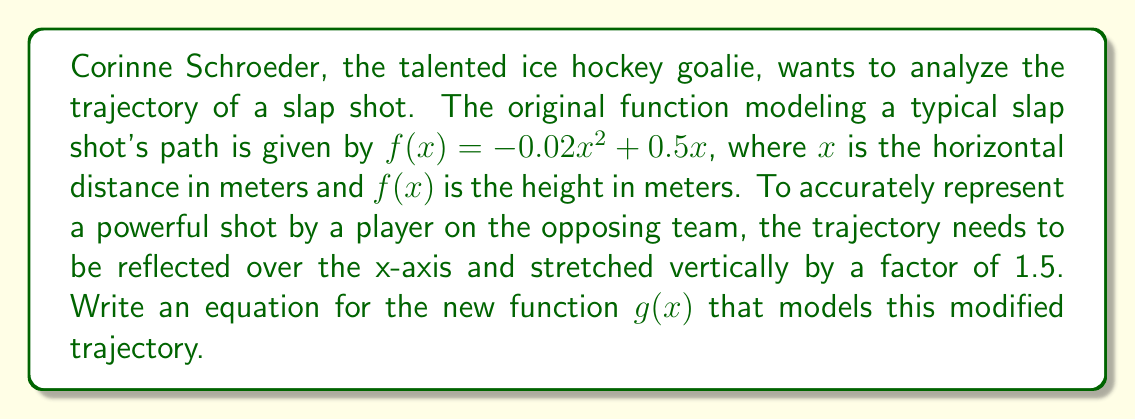Provide a solution to this math problem. To solve this problem, we need to apply two transformations to the original function $f(x) = -0.02x^2 + 0.5x$:

1. Reflect over the x-axis: This is done by multiplying the entire function by -1.
   $-f(x) = -(-0.02x^2 + 0.5x) = 0.02x^2 - 0.5x$

2. Stretch vertically by a factor of 1.5: This is achieved by multiplying the function by 1.5.
   $1.5 \cdot (-f(x)) = 1.5(0.02x^2 - 0.5x)$

Combining these transformations, we get:

$g(x) = 1.5(0.02x^2 - 0.5x)$

Simplifying:
$g(x) = 1.5(0.02x^2) - 1.5(0.5x)$
$g(x) = 0.03x^2 - 0.75x$

Therefore, the new function $g(x)$ that models the reflected and stretched trajectory of the slap shot is $g(x) = 0.03x^2 - 0.75x$.
Answer: $g(x) = 0.03x^2 - 0.75x$ 